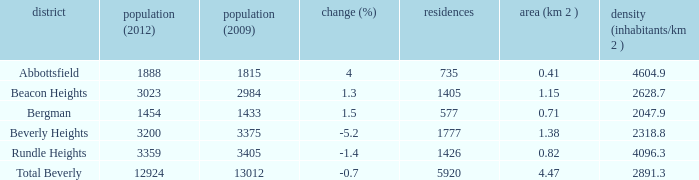What is the density of an area that is 1.38km and has a population more than 12924? 0.0. 